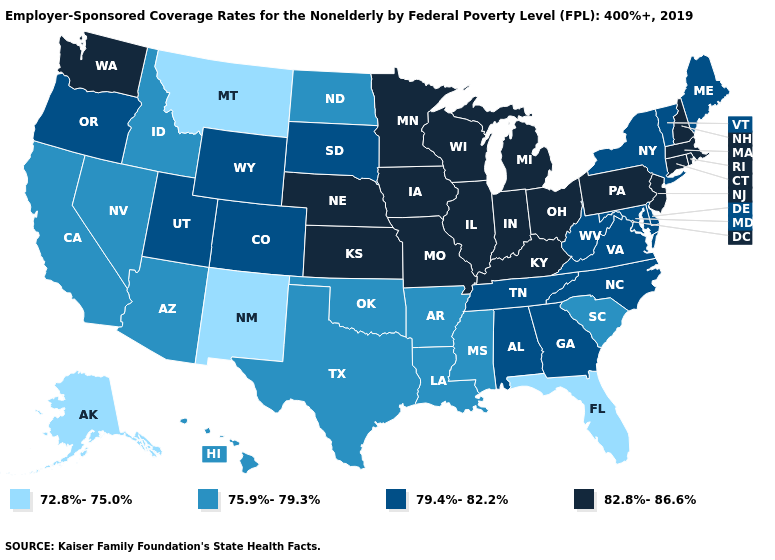Name the states that have a value in the range 79.4%-82.2%?
Write a very short answer. Alabama, Colorado, Delaware, Georgia, Maine, Maryland, New York, North Carolina, Oregon, South Dakota, Tennessee, Utah, Vermont, Virginia, West Virginia, Wyoming. How many symbols are there in the legend?
Concise answer only. 4. Does Washington have the highest value in the West?
Give a very brief answer. Yes. Which states have the lowest value in the USA?
Answer briefly. Alaska, Florida, Montana, New Mexico. Among the states that border Kentucky , which have the lowest value?
Answer briefly. Tennessee, Virginia, West Virginia. Does Arizona have the same value as Nevada?
Answer briefly. Yes. Does the map have missing data?
Write a very short answer. No. What is the lowest value in the USA?
Be succinct. 72.8%-75.0%. Does Kansas have the highest value in the USA?
Give a very brief answer. Yes. What is the value of Mississippi?
Concise answer only. 75.9%-79.3%. Which states hav the highest value in the MidWest?
Write a very short answer. Illinois, Indiana, Iowa, Kansas, Michigan, Minnesota, Missouri, Nebraska, Ohio, Wisconsin. Name the states that have a value in the range 79.4%-82.2%?
Give a very brief answer. Alabama, Colorado, Delaware, Georgia, Maine, Maryland, New York, North Carolina, Oregon, South Dakota, Tennessee, Utah, Vermont, Virginia, West Virginia, Wyoming. Name the states that have a value in the range 75.9%-79.3%?
Be succinct. Arizona, Arkansas, California, Hawaii, Idaho, Louisiana, Mississippi, Nevada, North Dakota, Oklahoma, South Carolina, Texas. Name the states that have a value in the range 75.9%-79.3%?
Write a very short answer. Arizona, Arkansas, California, Hawaii, Idaho, Louisiana, Mississippi, Nevada, North Dakota, Oklahoma, South Carolina, Texas. What is the lowest value in the USA?
Be succinct. 72.8%-75.0%. 